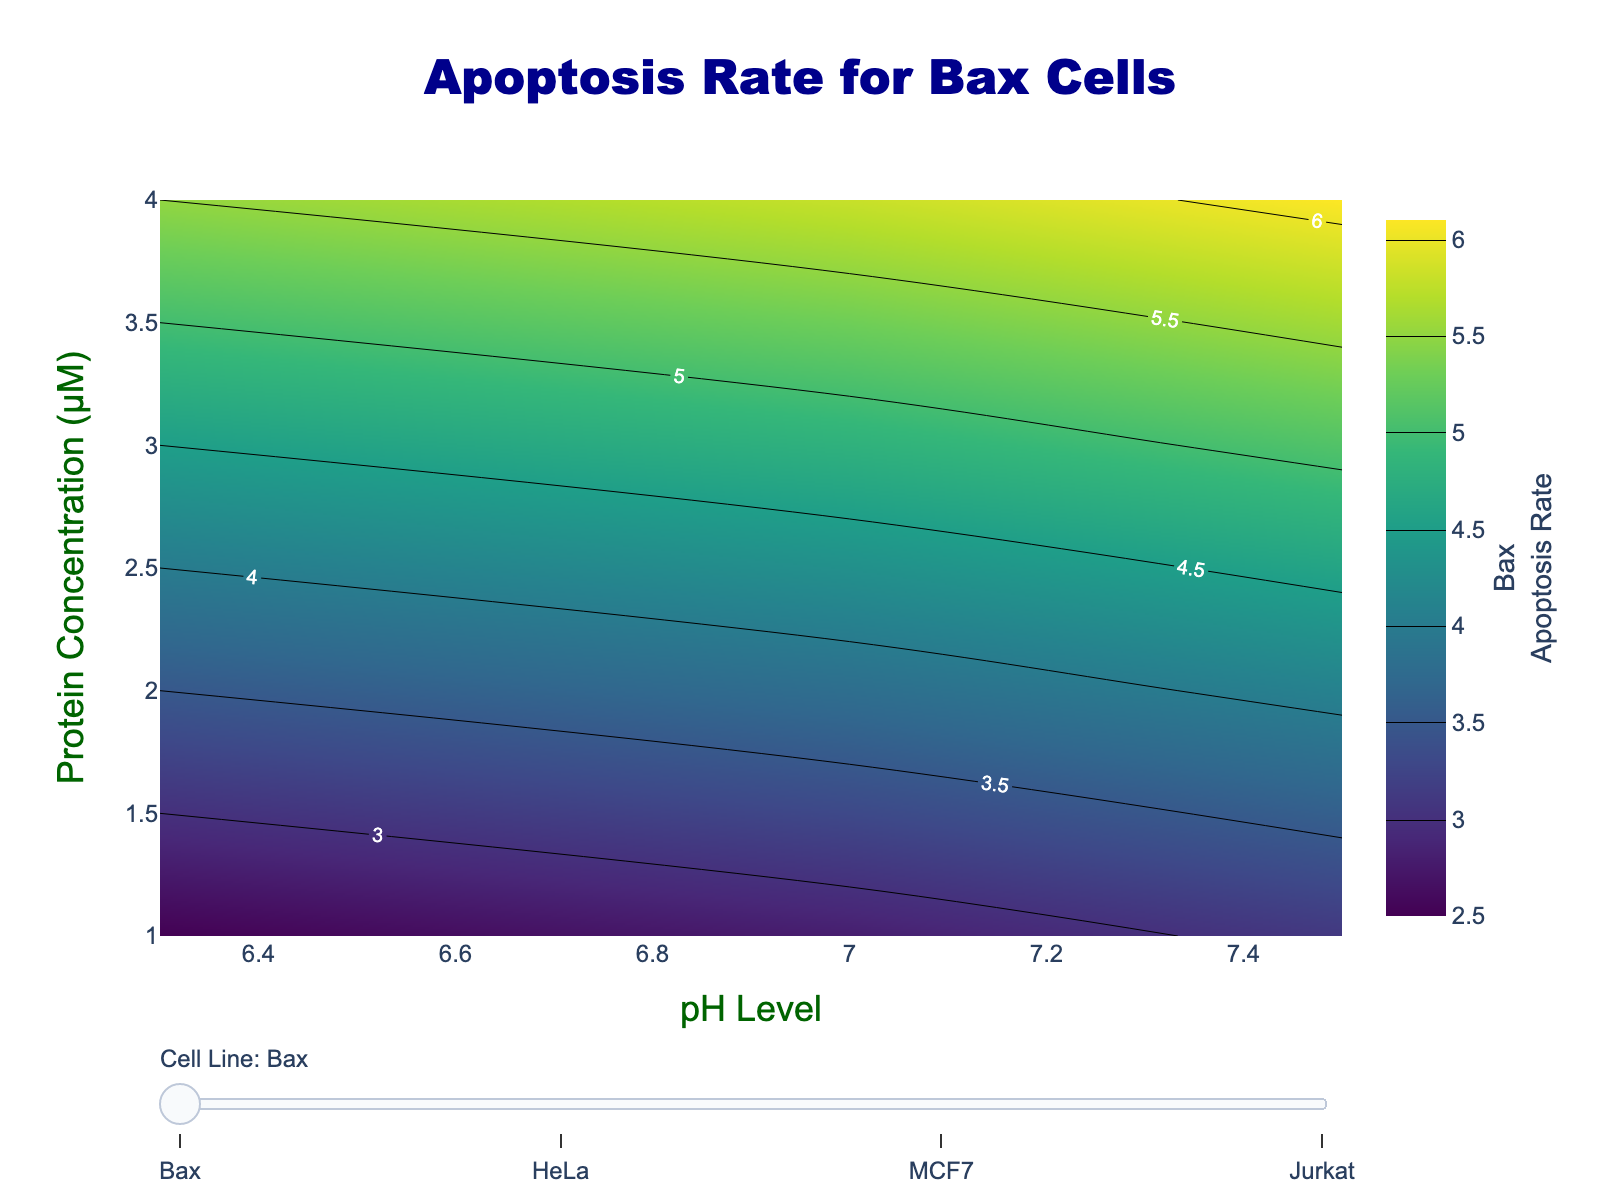what is the color representing the highest apoptosis rate in Bax cells at Protein Concentration 4.0 μM and pH Level 7.5? Look at the color scale corresponding to the Bax cells at Protein Concentration 4.0 μM and pH Level 7.5. The highest rate is 6.1, and from the colorscale, this matches a dark green color.
Answer: dark green Which cell line shows the highest apoptosis rate at pH Level 6.3 and Protein Concentration 1.0 μM? Compare the apoptosis rates across all cell lines at pH Level 6.3 and Protein Concentration 1.0 μM. Jurkat has the highest rate of 6.8.
Answer: Jurkat How does the apoptosis rate in HeLa cells change between pH Level 6.3 and 7.0 for Protein Concentration 2.0 μM? Look at the apoptosis rate for HeLa cells at Protein Concentration 2.0 μM for pH Levels 6.3 and 7.0. The rates are 6.8 and 7.2, respectively. The change is 7.2 - 6.8 = 0.4 increase.
Answer: increase 0.4 For MCF7 cells, what is the difference in apoptosis rate between Protein Concentration 1.0 μM and 4.0 μM at pH Level 7.5? Check the apoptosis rates for MCF7 cells at Protein Concentration 1.0 μM and 4.0 μM at pH Level 7.5. The rates are 3.9 and 6.9 respectively; the difference is 6.9 - 3.9 = 3.0.
Answer: 3.0 Which cell line exhibits the most gradual increase in apoptosis rate with increasing Protein Concentration at pH Level 7.0? Look at the apoptosis rates for each cell line at pH Level 7.0 as Protein Concentration increases from 1.0 μM to 4.0 μM. Compare the increments. HeLa has a gradual increase (5.6, 7.2, 8.8, 10.8).
Answer: HeLa At Protein Concentration 3.0 μM across all cell lines, which pH Level shows the lowest apoptosis rate for Bax cells? Review the apoptosis rates for Bax cells at Protein Concentration 3.0 μM across different pH Levels (6.3: 4.5, 7.0: 4.8, 7.5: 5.1). The lowest rate is at pH 6.3.
Answer: 6.3 For Jurkat cells, what is the average apoptosis rate across all pH Levels at Protein Concentration 3.0 μM? Find the apoptosis rates for Jurkat cells at Protein Concentration 3.0 μM for all pH Levels. The values are 9.2, 9.6, and 10.0. The average is (9.2 + 9.6 + 10.0) / 3 = 9.6.
Answer: 9.6 What is the general trend of apoptosis rates in MCF7 cells as Protein Concentration increases from 1.0 μM to 4.0 μM at pH Level 6.3? Observe the apoptosis rates of MCF7 cells at pH Level 6.3 as Protein Concentration increases: 3.1, 4.2, 5.3, 6.3. The trend is a gradual increase.
Answer: increasing Which cell line has the highest overall apoptosis rate at pH Level 7.5 for all Protein Concentrations combined? Examine the apoptosis rates at pH Level 7.5 for all cell lines across different Protein Concentrations. Jurkat shows the highest overall rates (7.6, 8.7, 10.0, 11.3).
Answer: Jurkat 